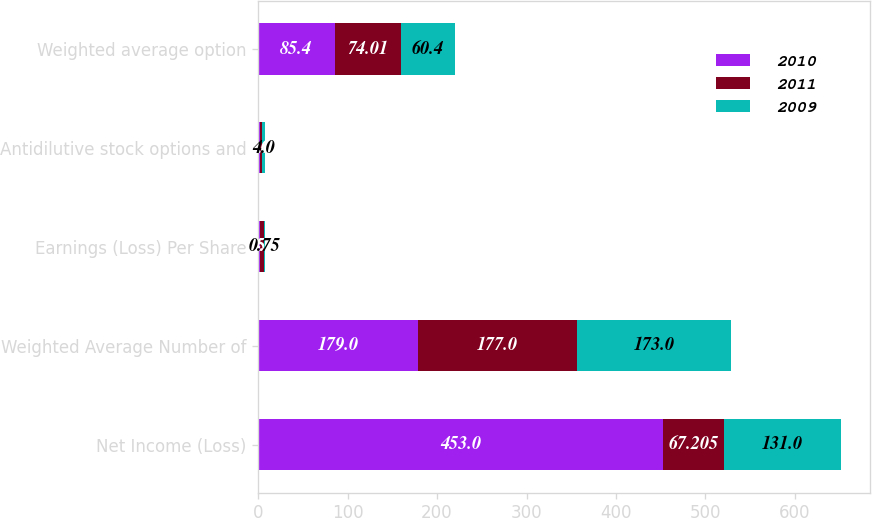Convert chart to OTSL. <chart><loc_0><loc_0><loc_500><loc_500><stacked_bar_chart><ecel><fcel>Net Income (Loss)<fcel>Weighted Average Number of<fcel>Earnings (Loss) Per Share<fcel>Antidilutive stock options and<fcel>Weighted average option<nl><fcel>2010<fcel>453<fcel>179<fcel>2.54<fcel>2<fcel>85.4<nl><fcel>2011<fcel>67.205<fcel>177<fcel>4.1<fcel>2<fcel>74.01<nl><fcel>2009<fcel>131<fcel>173<fcel>0.75<fcel>4<fcel>60.4<nl></chart> 